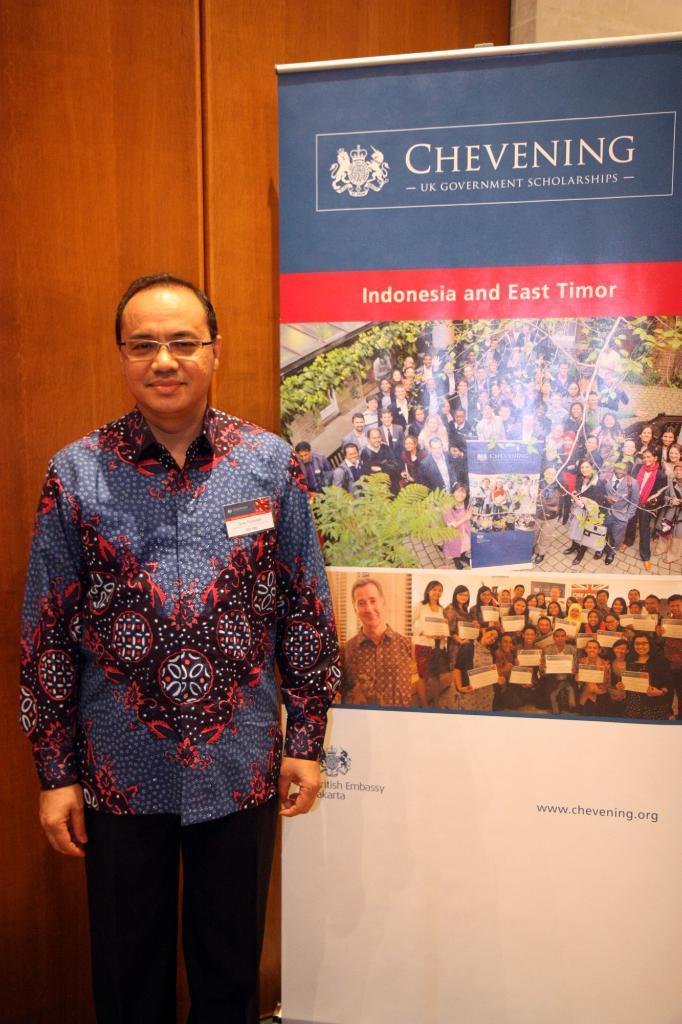In one or two sentences, can you explain what this image depicts? In the picture there is a person standing near banner, there is a text and photographs present on the banner, behind the person there is a wall. 